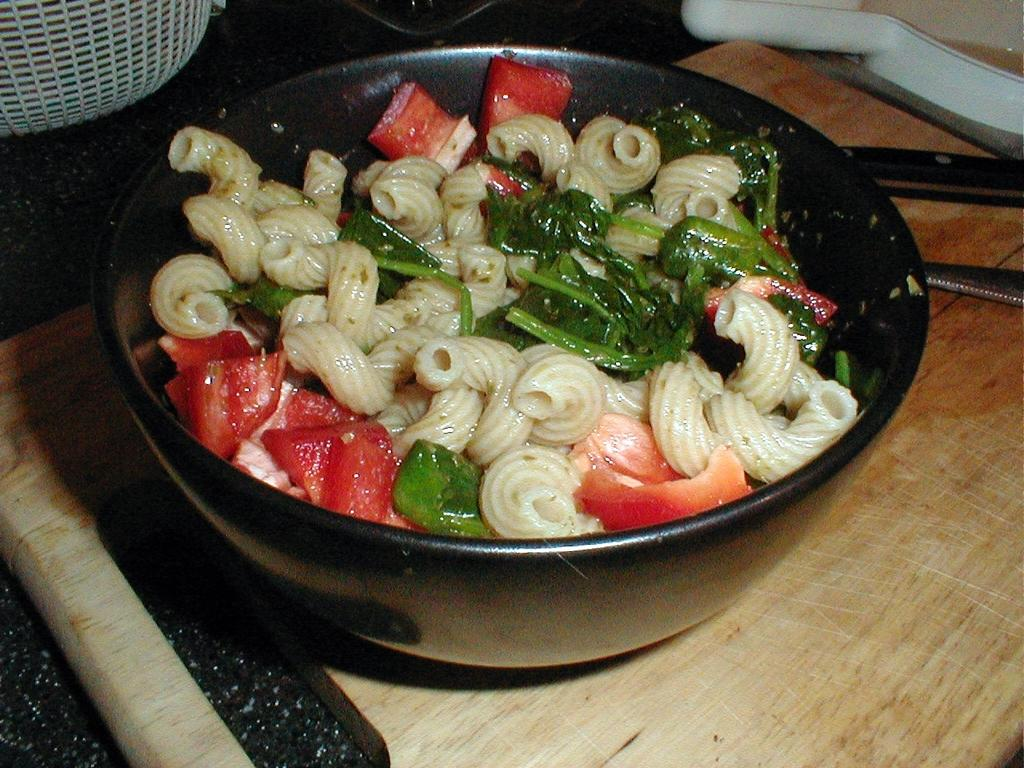What is the main object on the wooden cutting plank in the image? There is a bowl on a wooden cutting plank in the image. What is inside the bowl? The bowl contains food items. What other item can be seen in the image besides the bowl? There is a basket in the image. Are there any other objects present in the image? Yes, there are other objects present in the image. Where are all these items placed? All these items are placed on a platform. What type of power line can be seen running through the image? There is no power line visible in the image. What is the front view of the bowl in the image? The provided facts do not give information about the front view of the bowl, only that it is on a wooden cutting plank and contains food items. 